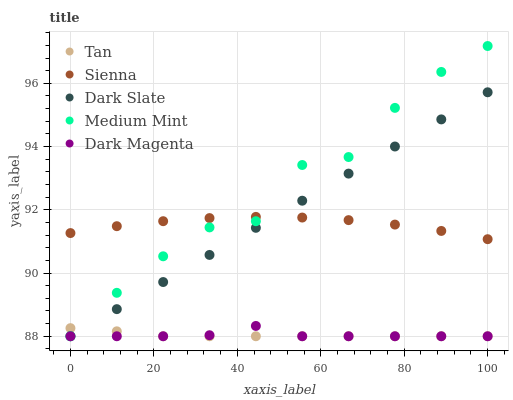Does Tan have the minimum area under the curve?
Answer yes or no. Yes. Does Medium Mint have the maximum area under the curve?
Answer yes or no. Yes. Does Dark Slate have the minimum area under the curve?
Answer yes or no. No. Does Dark Slate have the maximum area under the curve?
Answer yes or no. No. Is Dark Slate the smoothest?
Answer yes or no. Yes. Is Medium Mint the roughest?
Answer yes or no. Yes. Is Tan the smoothest?
Answer yes or no. No. Is Tan the roughest?
Answer yes or no. No. Does Dark Slate have the lowest value?
Answer yes or no. Yes. Does Medium Mint have the highest value?
Answer yes or no. Yes. Does Dark Slate have the highest value?
Answer yes or no. No. Is Tan less than Sienna?
Answer yes or no. Yes. Is Sienna greater than Tan?
Answer yes or no. Yes. Does Sienna intersect Dark Slate?
Answer yes or no. Yes. Is Sienna less than Dark Slate?
Answer yes or no. No. Is Sienna greater than Dark Slate?
Answer yes or no. No. Does Tan intersect Sienna?
Answer yes or no. No. 